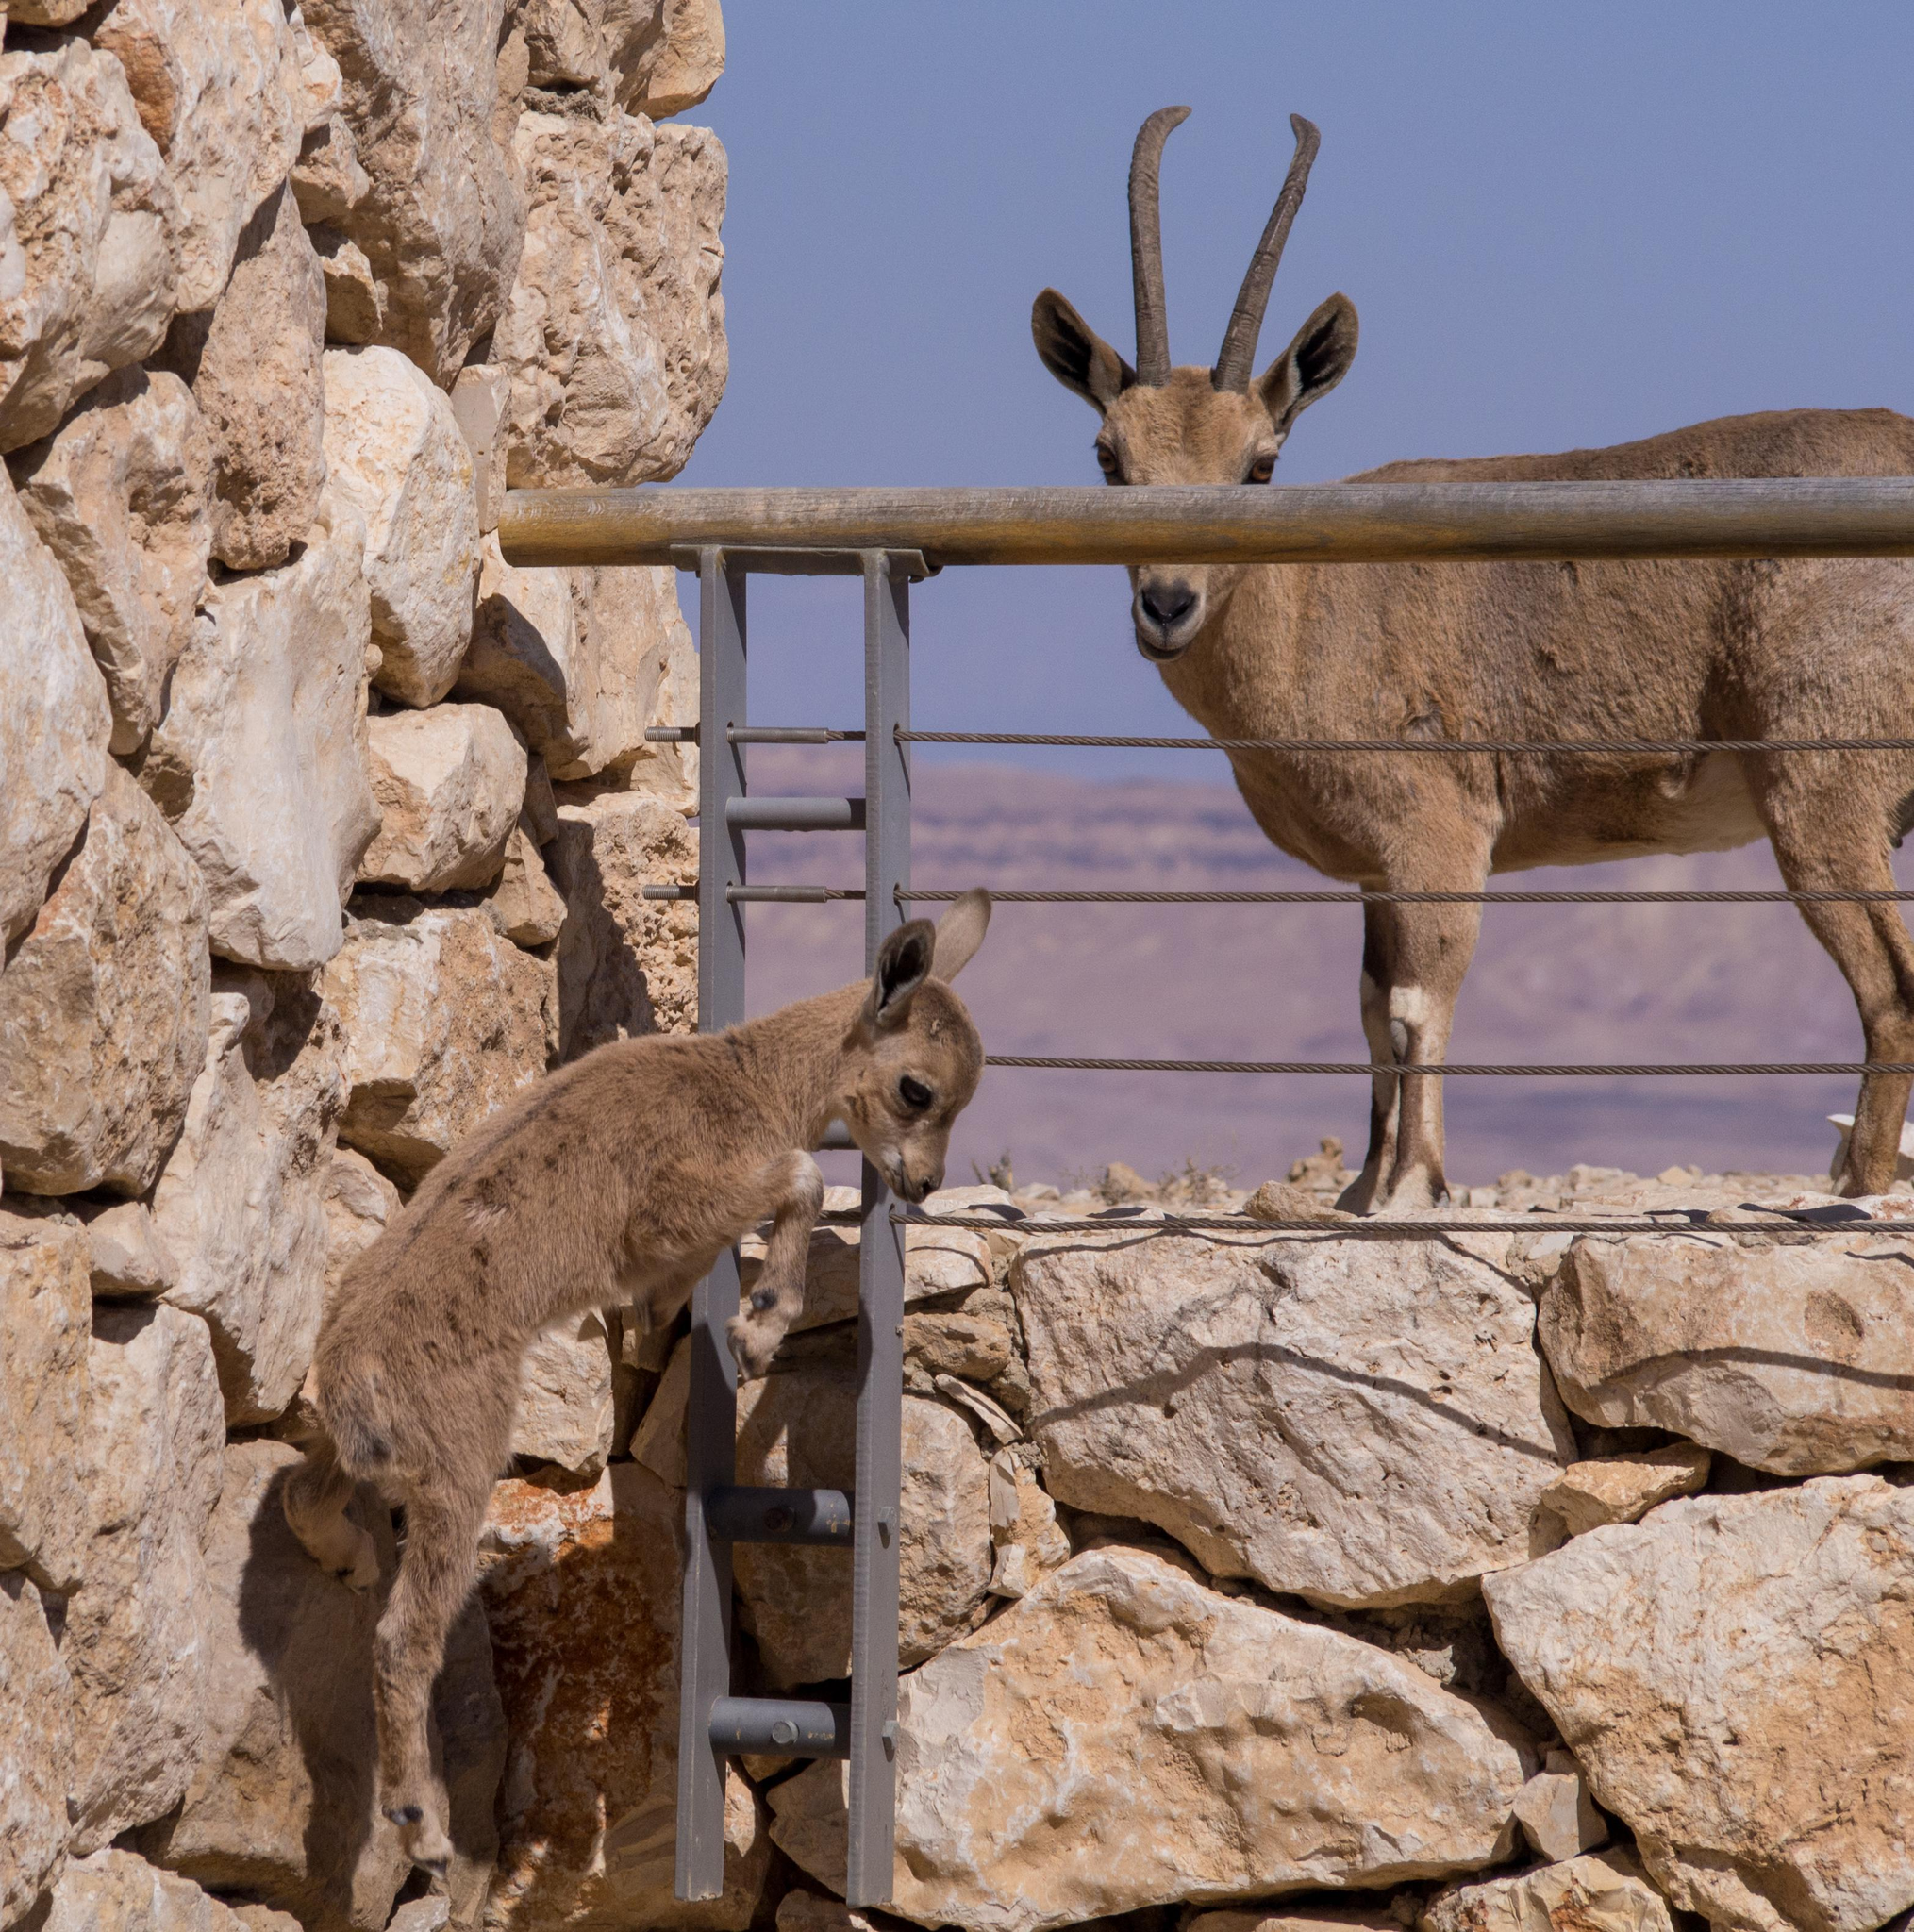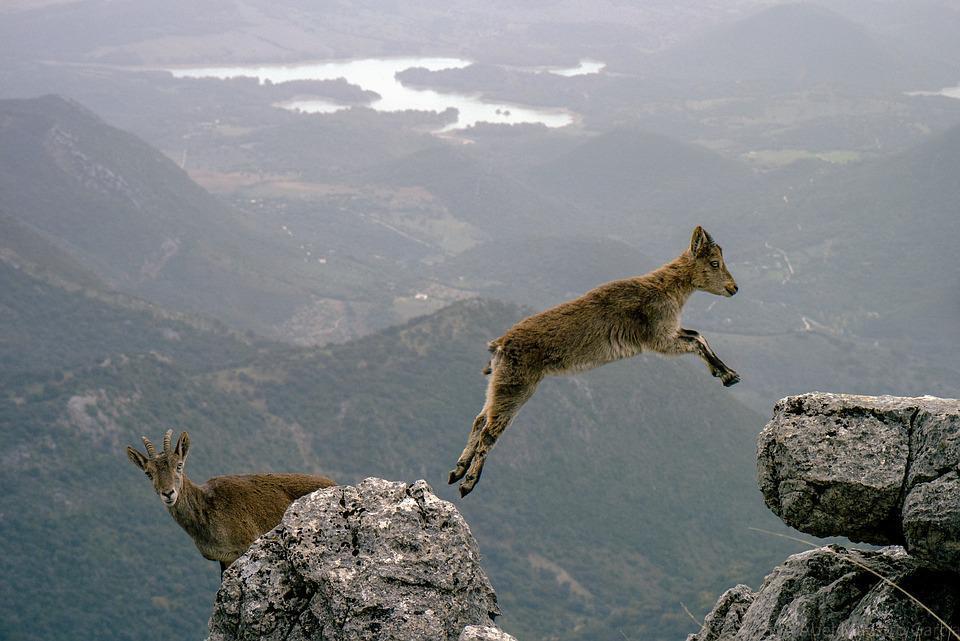The first image is the image on the left, the second image is the image on the right. Evaluate the accuracy of this statement regarding the images: "A cloven animal is leaping and all four hooves are off of the ground.". Is it true? Answer yes or no. Yes. 